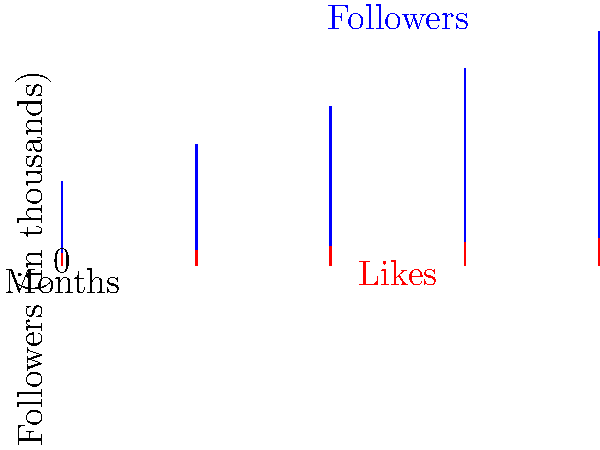As a social media influencer, you've been tracking your growth over the past 5 months. The blue bars represent your followers (in thousands), and the red bars represent your average likes per post (in thousands). Calculate your engagement rate for the most recent month, expressing it as a percentage. Round your answer to the nearest hundredth. To calculate the engagement rate, we'll follow these steps:

1. Identify the most recent month's data (Month 5):
   Followers: 150,000
   Likes: 12,000

2. Use the formula for engagement rate:
   $\text{Engagement Rate} = \frac{\text{Likes}}{\text{Followers}} \times 100\%$

3. Plug in the values:
   $\text{Engagement Rate} = \frac{12,000}{150,000} \times 100\%$

4. Simplify:
   $\text{Engagement Rate} = 0.08 \times 100\% = 8\%$

5. Round to the nearest hundredth:
   8.00%

This engagement rate indicates that, on average, 8% of your followers are interacting with your posts through likes.
Answer: 8.00% 